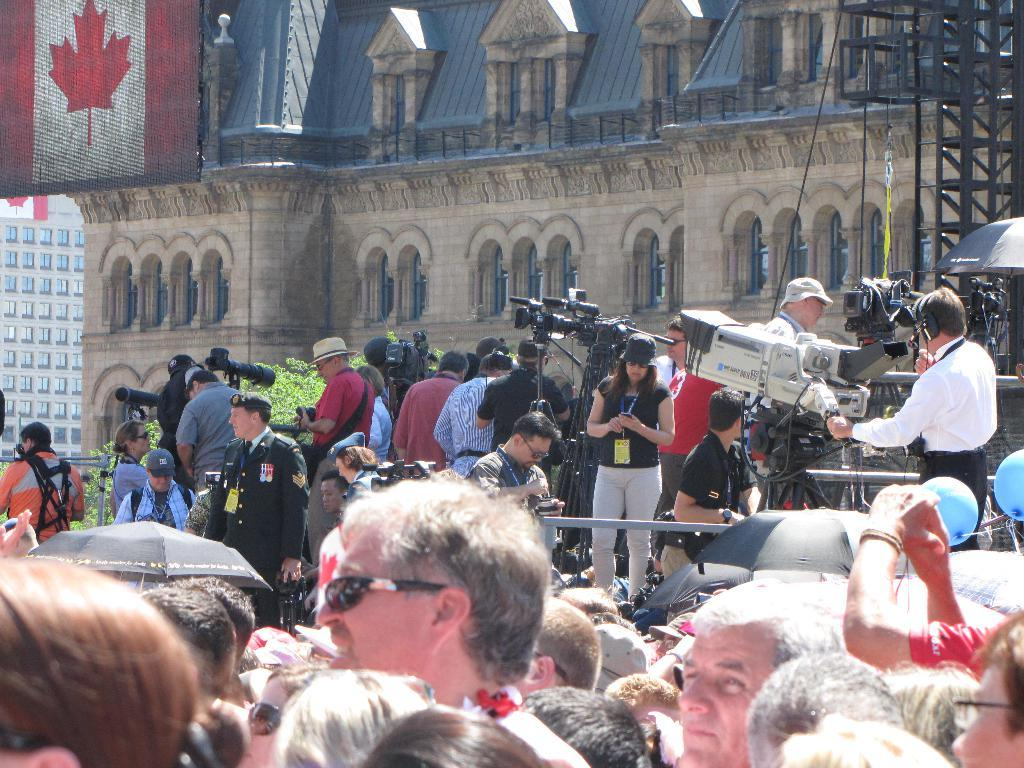Where was the image taken? The image is taken outside. What can be seen in the background of the image? There is a building visible in the image. How many people are in the image? There are multiple persons in the image. What are some of the persons doing in the image? Some of the persons are holding cameras. Where is the sink located in the image? There is no sink present in the image. What type of bit is being used by the persons in the image? There is no bit present in the image; the persons are holding cameras. 